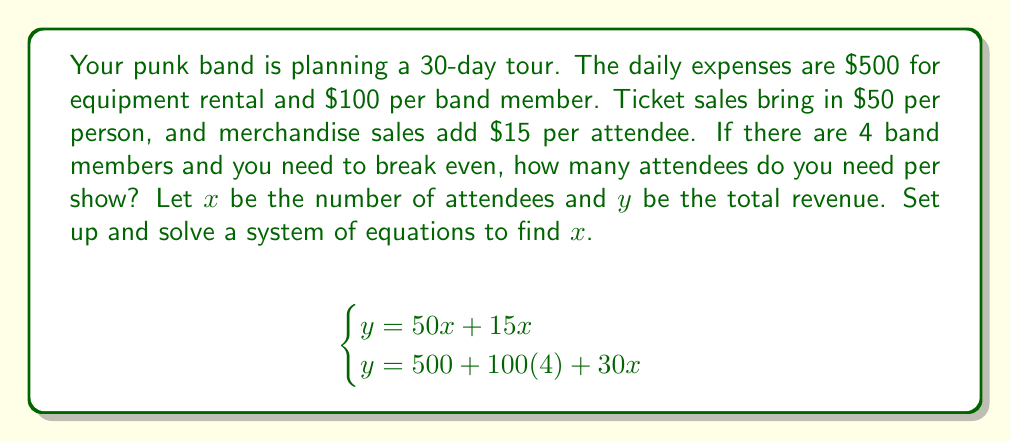Can you solve this math problem? Let's solve this system of equations step by step:

1) From the first equation:
   $y = 50x + 15x = 65x$

2) From the second equation:
   $y = 500 + 100(4) + 30x = 900 + 30x$

3) Since both equations equal $y$, we can set them equal to each other:
   $65x = 900 + 30x$

4) Subtract $30x$ from both sides:
   $35x = 900$

5) Divide both sides by 35:
   $x = \frac{900}{35} = 25.71$

6) Since we can't have a fractional number of attendees, we round up to the nearest whole number:
   $x = 26$

Therefore, you need at least 26 attendees per show to break even.

To verify:
Revenue: $26 * (50 + 15) = 26 * 65 = 1690$
Expenses: $500 + (4 * 100) = 900$
Daily profit: $1690 - 900 = 790$

This confirms that 26 attendees will allow the band to break even and start making a profit.
Answer: 26 attendees 